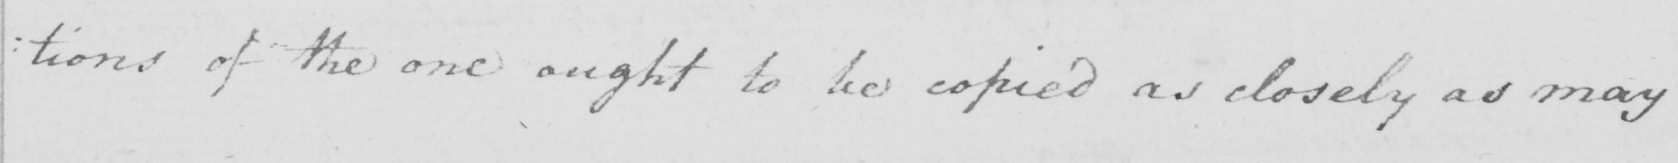Can you tell me what this handwritten text says? : tions of the one ought to be copied as closely as may 